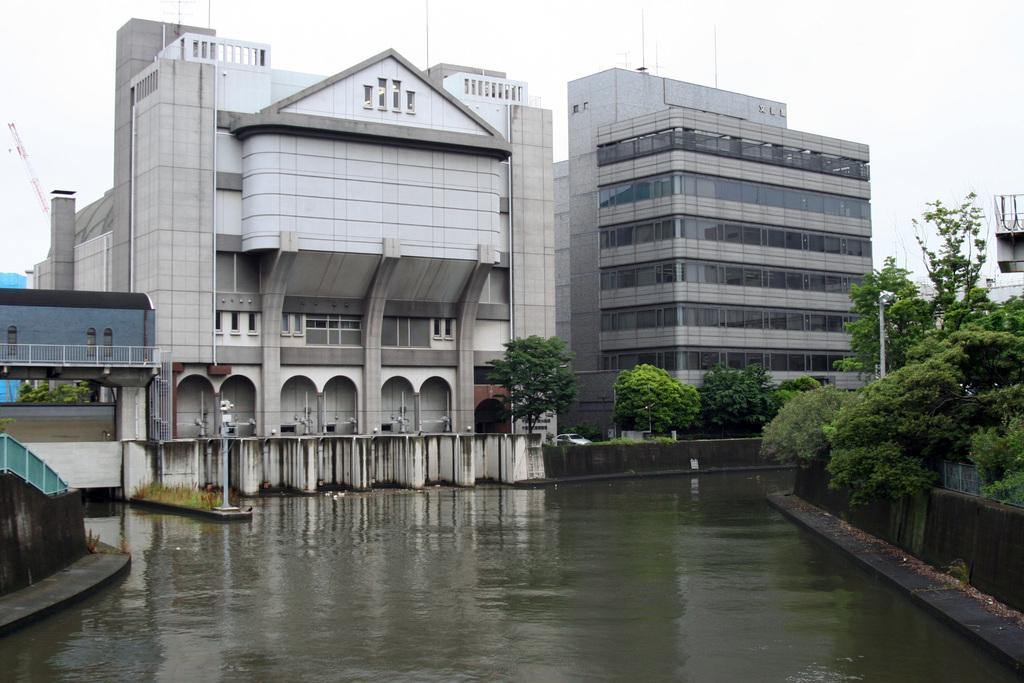What is located in the foreground of the image? There are plants and a water surface in the foreground of the image. What can be seen in the background of the image? There are buildings, poles, trees, and the sky visible in the background of the image. What type of songs can be heard coming from the buildings in the image? There is no indication in the image that any songs are being played or heard from the buildings. What idea is being conveyed by the plants in the foreground of the image? The image does not convey any specific ideas or messages; it simply depicts plants and a water surface in the foreground. 